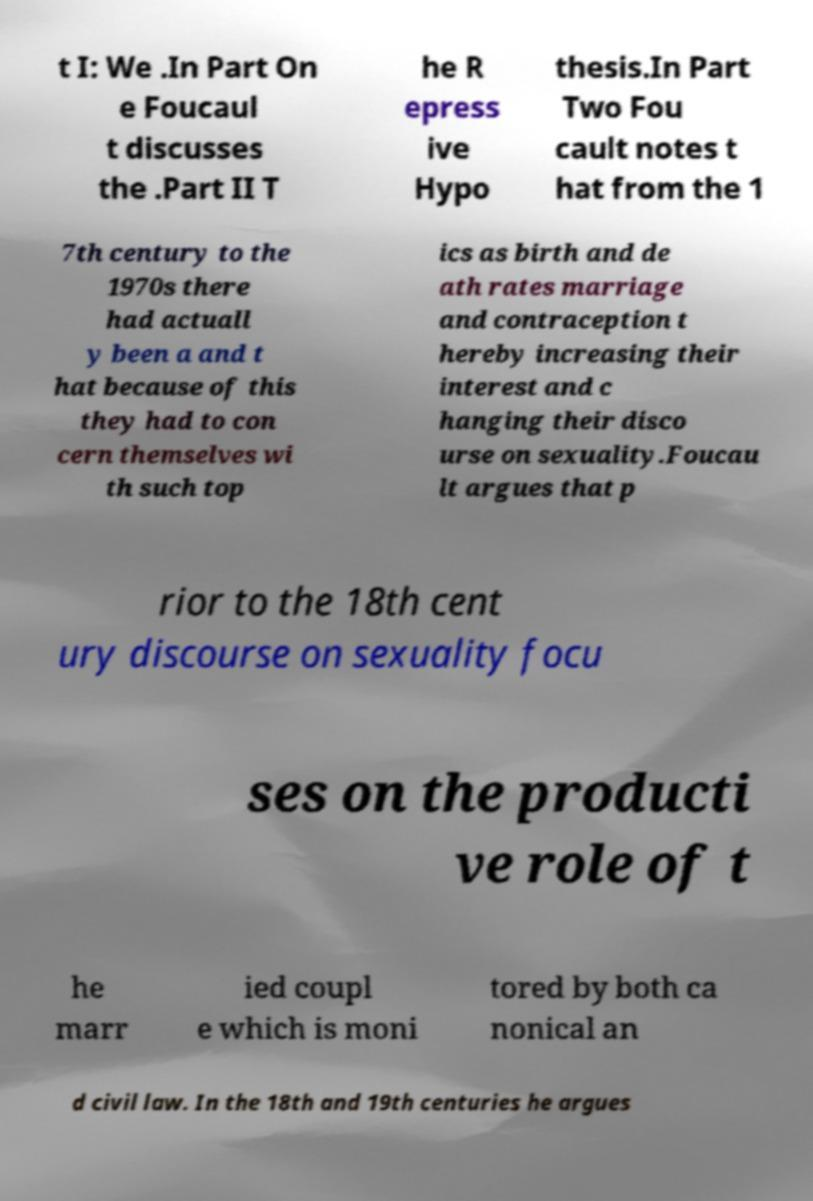Please identify and transcribe the text found in this image. t I: We .In Part On e Foucaul t discusses the .Part II T he R epress ive Hypo thesis.In Part Two Fou cault notes t hat from the 1 7th century to the 1970s there had actuall y been a and t hat because of this they had to con cern themselves wi th such top ics as birth and de ath rates marriage and contraception t hereby increasing their interest and c hanging their disco urse on sexuality.Foucau lt argues that p rior to the 18th cent ury discourse on sexuality focu ses on the producti ve role of t he marr ied coupl e which is moni tored by both ca nonical an d civil law. In the 18th and 19th centuries he argues 